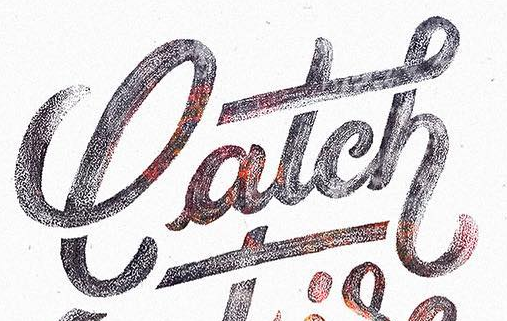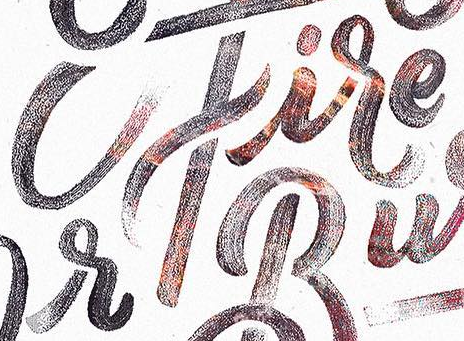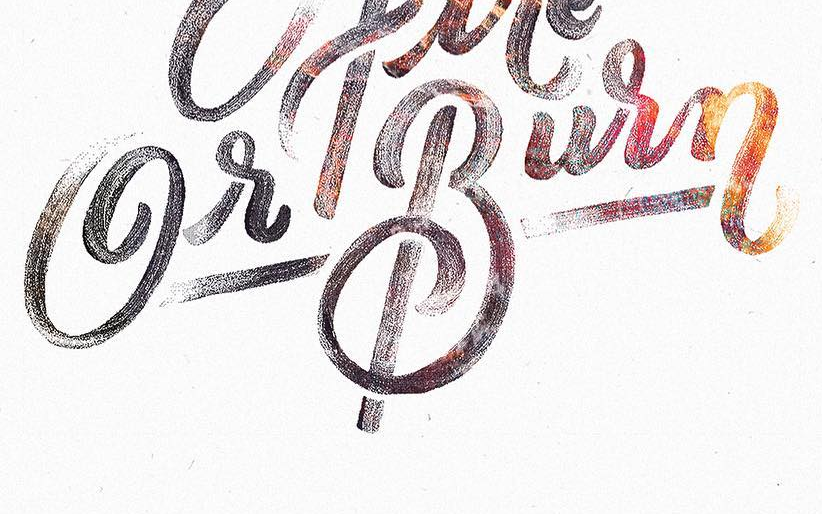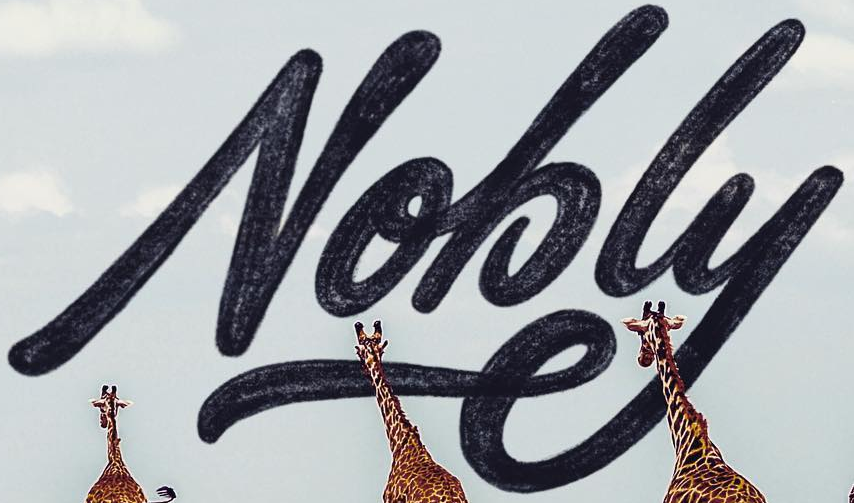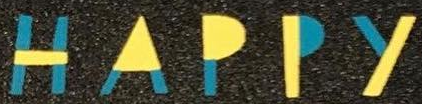Transcribe the words shown in these images in order, separated by a semicolon. latch; cfire; GrBurn; Nobly; HAPPY 